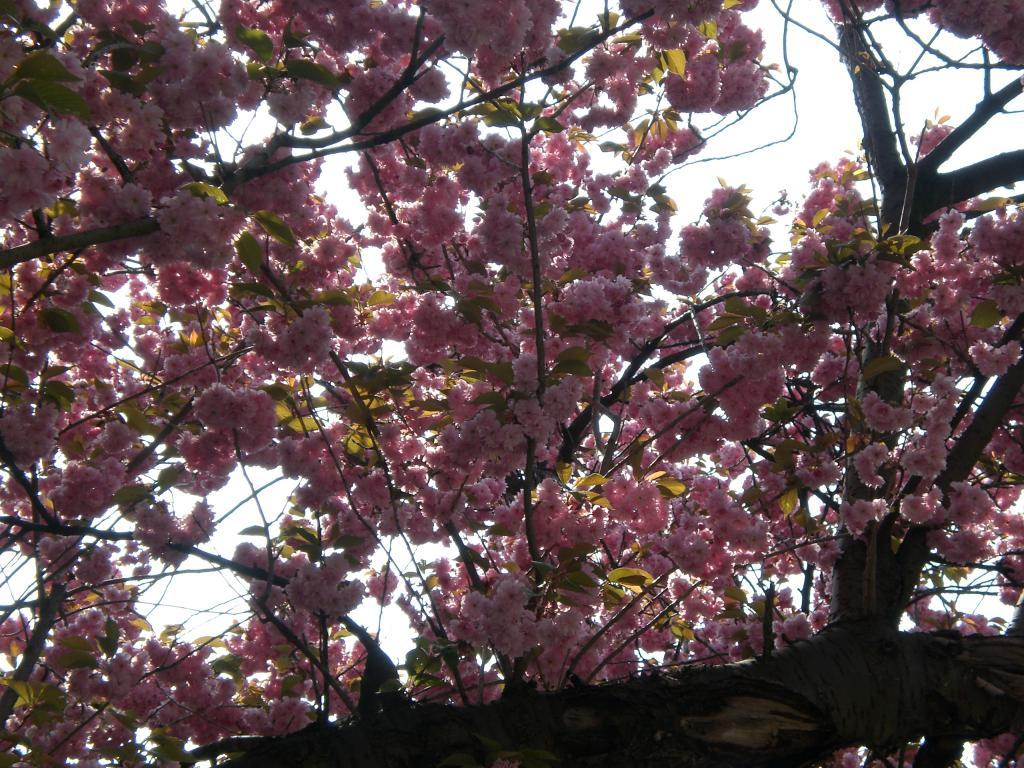What type of flowers are present in the image? There are pink color flowers in the image. What can be seen in the background of the image? There is a sky visible in the background of the image. How does the foot of the person in the image help the flowers grow? There is no person present in the image, and therefore no foot to help the flowers grow. 